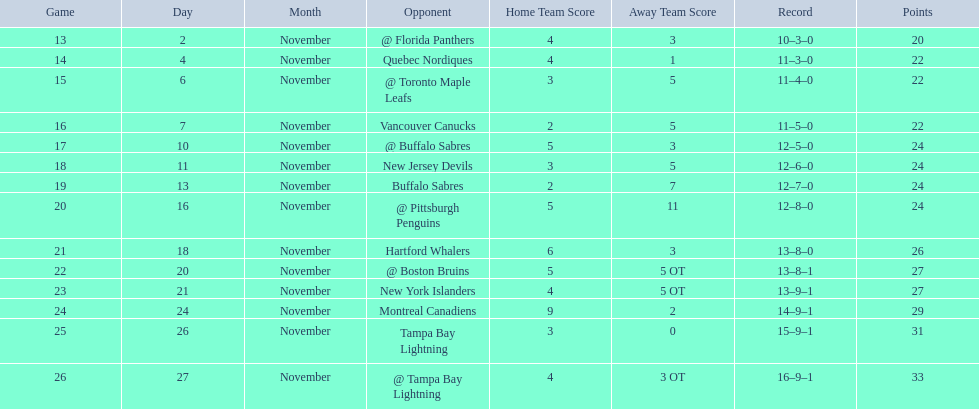What are the teams in the atlantic division? Quebec Nordiques, Vancouver Canucks, New Jersey Devils, Buffalo Sabres, Hartford Whalers, New York Islanders, Montreal Canadiens, Tampa Bay Lightning. Which of those scored fewer points than the philadelphia flyers? Tampa Bay Lightning. 